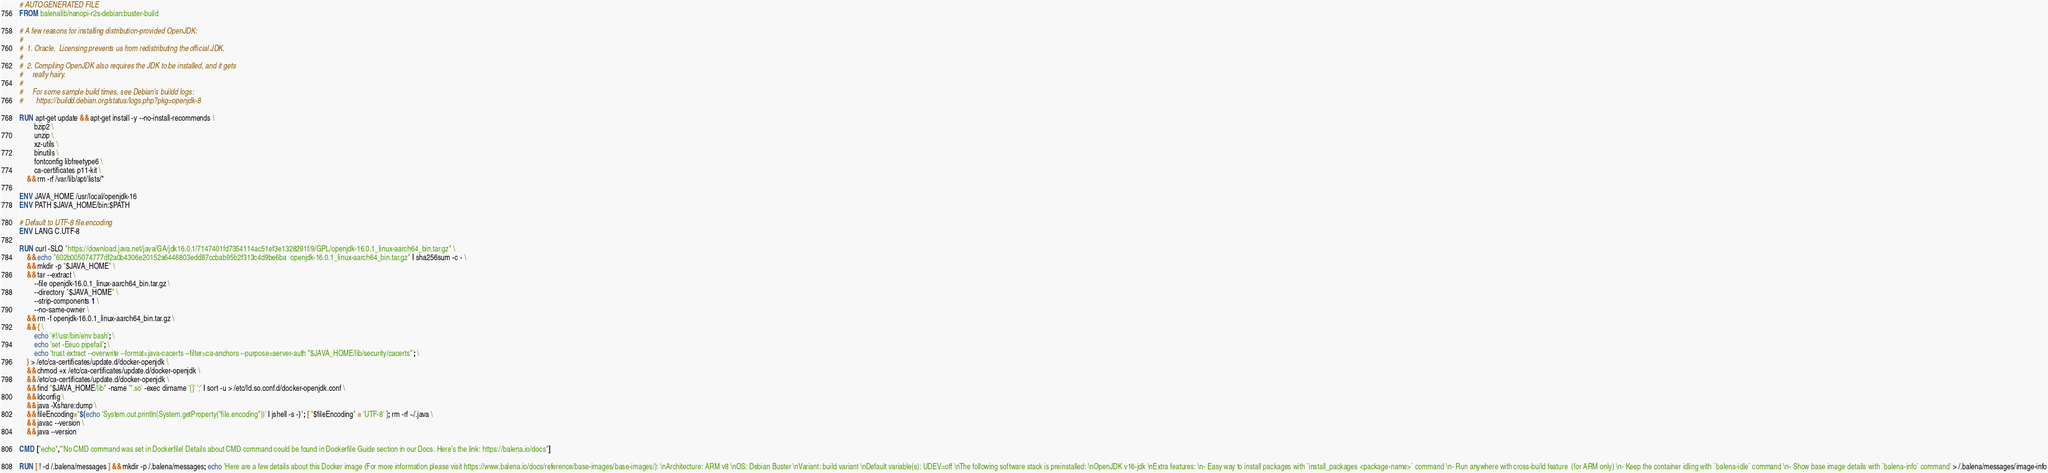<code> <loc_0><loc_0><loc_500><loc_500><_Dockerfile_># AUTOGENERATED FILE
FROM balenalib/nanopi-r2s-debian:buster-build

# A few reasons for installing distribution-provided OpenJDK:
#
#  1. Oracle.  Licensing prevents us from redistributing the official JDK.
#
#  2. Compiling OpenJDK also requires the JDK to be installed, and it gets
#     really hairy.
#
#     For some sample build times, see Debian's buildd logs:
#       https://buildd.debian.org/status/logs.php?pkg=openjdk-8

RUN apt-get update && apt-get install -y --no-install-recommends \
		bzip2 \
		unzip \
		xz-utils \
		binutils \
		fontconfig libfreetype6 \
		ca-certificates p11-kit \
	&& rm -rf /var/lib/apt/lists/*

ENV JAVA_HOME /usr/local/openjdk-16
ENV PATH $JAVA_HOME/bin:$PATH

# Default to UTF-8 file.encoding
ENV LANG C.UTF-8

RUN curl -SLO "https://download.java.net/java/GA/jdk16.0.1/7147401fd7354114ac51ef3e1328291f/9/GPL/openjdk-16.0.1_linux-aarch64_bin.tar.gz" \
	&& echo "602b005074777df2a0b4306e20152a6446803edd87ccbab95b2f313c4d9be6ba  openjdk-16.0.1_linux-aarch64_bin.tar.gz" | sha256sum -c - \
	&& mkdir -p "$JAVA_HOME" \
	&& tar --extract \
		--file openjdk-16.0.1_linux-aarch64_bin.tar.gz \
		--directory "$JAVA_HOME" \
		--strip-components 1 \
		--no-same-owner \
	&& rm -f openjdk-16.0.1_linux-aarch64_bin.tar.gz \
	&& { \
		echo '#!/usr/bin/env bash'; \
		echo 'set -Eeuo pipefail'; \
		echo 'trust extract --overwrite --format=java-cacerts --filter=ca-anchors --purpose=server-auth "$JAVA_HOME/lib/security/cacerts"'; \
	} > /etc/ca-certificates/update.d/docker-openjdk \
	&& chmod +x /etc/ca-certificates/update.d/docker-openjdk \
	&& /etc/ca-certificates/update.d/docker-openjdk \
	&& find "$JAVA_HOME/lib" -name '*.so' -exec dirname '{}' ';' | sort -u > /etc/ld.so.conf.d/docker-openjdk.conf \
	&& ldconfig \
	&& java -Xshare:dump \
	&& fileEncoding="$(echo 'System.out.println(System.getProperty("file.encoding"))' | jshell -s -)"; [ "$fileEncoding" = 'UTF-8' ]; rm -rf ~/.java \
	&& javac --version \
	&& java --version

CMD ["echo","'No CMD command was set in Dockerfile! Details about CMD command could be found in Dockerfile Guide section in our Docs. Here's the link: https://balena.io/docs"]

RUN [ ! -d /.balena/messages ] && mkdir -p /.balena/messages; echo 'Here are a few details about this Docker image (For more information please visit https://www.balena.io/docs/reference/base-images/base-images/): \nArchitecture: ARM v8 \nOS: Debian Buster \nVariant: build variant \nDefault variable(s): UDEV=off \nThe following software stack is preinstalled: \nOpenJDK v16-jdk \nExtra features: \n- Easy way to install packages with `install_packages <package-name>` command \n- Run anywhere with cross-build feature  (for ARM only) \n- Keep the container idling with `balena-idle` command \n- Show base image details with `balena-info` command' > /.balena/messages/image-info</code> 